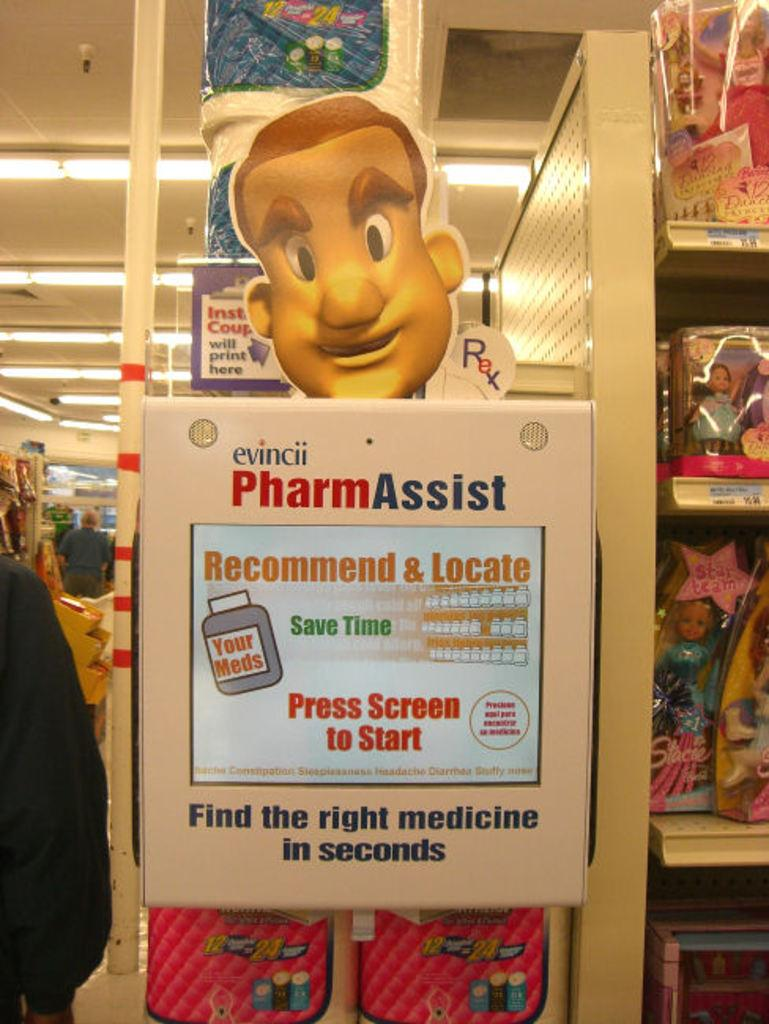What is the main object in the image? There is an advertisement board in the image. What are the dolls packed in? The dolls are packed in polythene cartons in the image. What is on the roof of the structure in the image? Electric lights are present on the roof in the image. Who is present on the floor in the image? There are people standing on the floor in the image. What type of machine is being operated by the beggar in the image? There is no beggar or machine present in the image. What color is the cloud in the image? There are no clouds present in the image. 